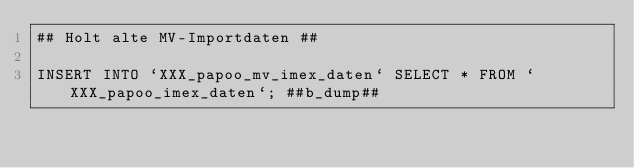<code> <loc_0><loc_0><loc_500><loc_500><_SQL_>## Holt alte MV-Importdaten ##

INSERT INTO `XXX_papoo_mv_imex_daten` SELECT * FROM `XXX_papoo_imex_daten`; ##b_dump##</code> 